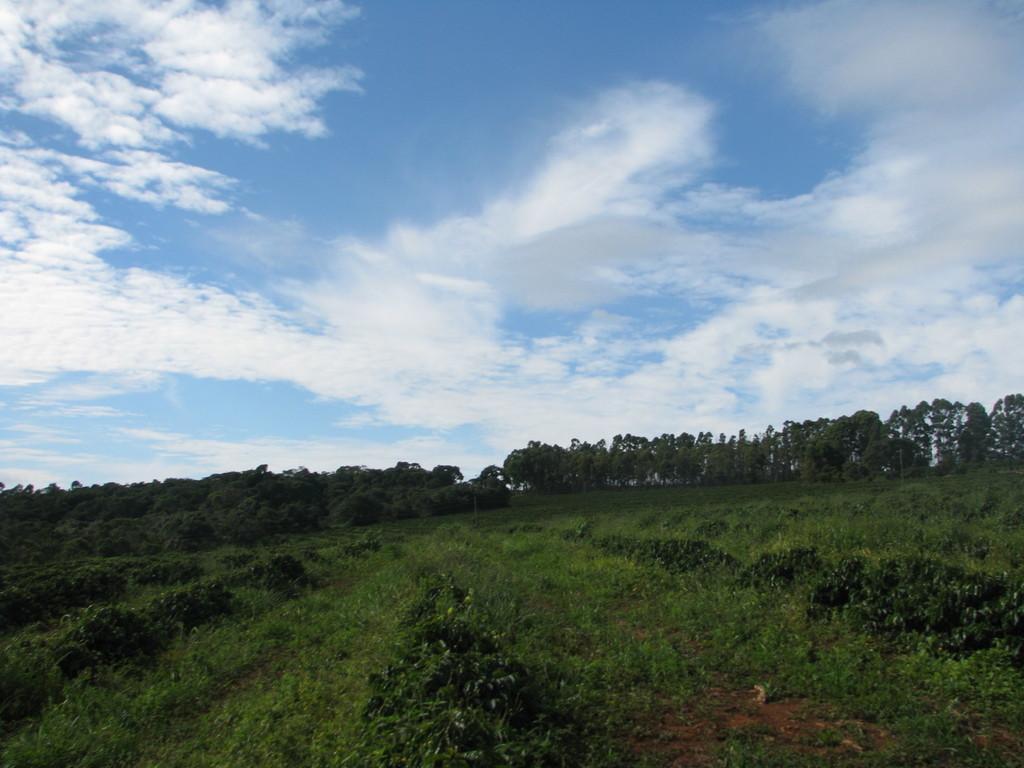Can you describe this image briefly? In this picture we can see few plants, trees and clouds. 